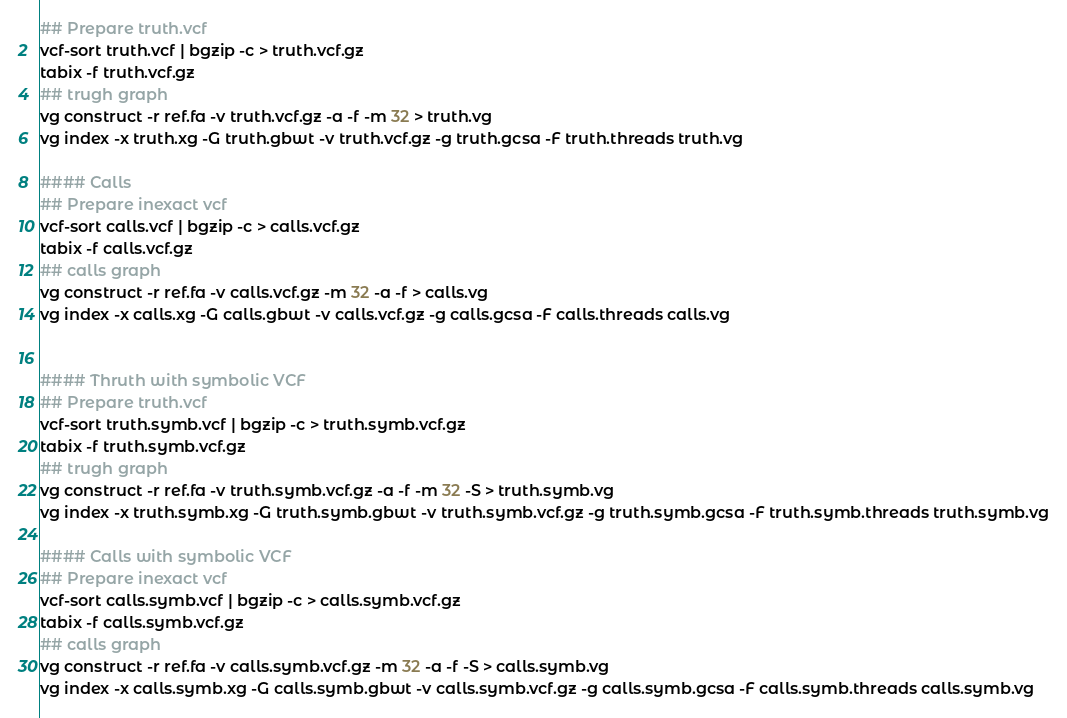Convert code to text. <code><loc_0><loc_0><loc_500><loc_500><_Bash_>## Prepare truth.vcf
vcf-sort truth.vcf | bgzip -c > truth.vcf.gz
tabix -f truth.vcf.gz
## trugh graph
vg construct -r ref.fa -v truth.vcf.gz -a -f -m 32 > truth.vg
vg index -x truth.xg -G truth.gbwt -v truth.vcf.gz -g truth.gcsa -F truth.threads truth.vg

#### Calls
## Prepare inexact vcf
vcf-sort calls.vcf | bgzip -c > calls.vcf.gz
tabix -f calls.vcf.gz
## calls graph
vg construct -r ref.fa -v calls.vcf.gz -m 32 -a -f > calls.vg
vg index -x calls.xg -G calls.gbwt -v calls.vcf.gz -g calls.gcsa -F calls.threads calls.vg


#### Thruth with symbolic VCF
## Prepare truth.vcf
vcf-sort truth.symb.vcf | bgzip -c > truth.symb.vcf.gz
tabix -f truth.symb.vcf.gz
## trugh graph
vg construct -r ref.fa -v truth.symb.vcf.gz -a -f -m 32 -S > truth.symb.vg
vg index -x truth.symb.xg -G truth.symb.gbwt -v truth.symb.vcf.gz -g truth.symb.gcsa -F truth.symb.threads truth.symb.vg

#### Calls with symbolic VCF
## Prepare inexact vcf
vcf-sort calls.symb.vcf | bgzip -c > calls.symb.vcf.gz
tabix -f calls.symb.vcf.gz
## calls graph
vg construct -r ref.fa -v calls.symb.vcf.gz -m 32 -a -f -S > calls.symb.vg
vg index -x calls.symb.xg -G calls.symb.gbwt -v calls.symb.vcf.gz -g calls.symb.gcsa -F calls.symb.threads calls.symb.vg
</code> 